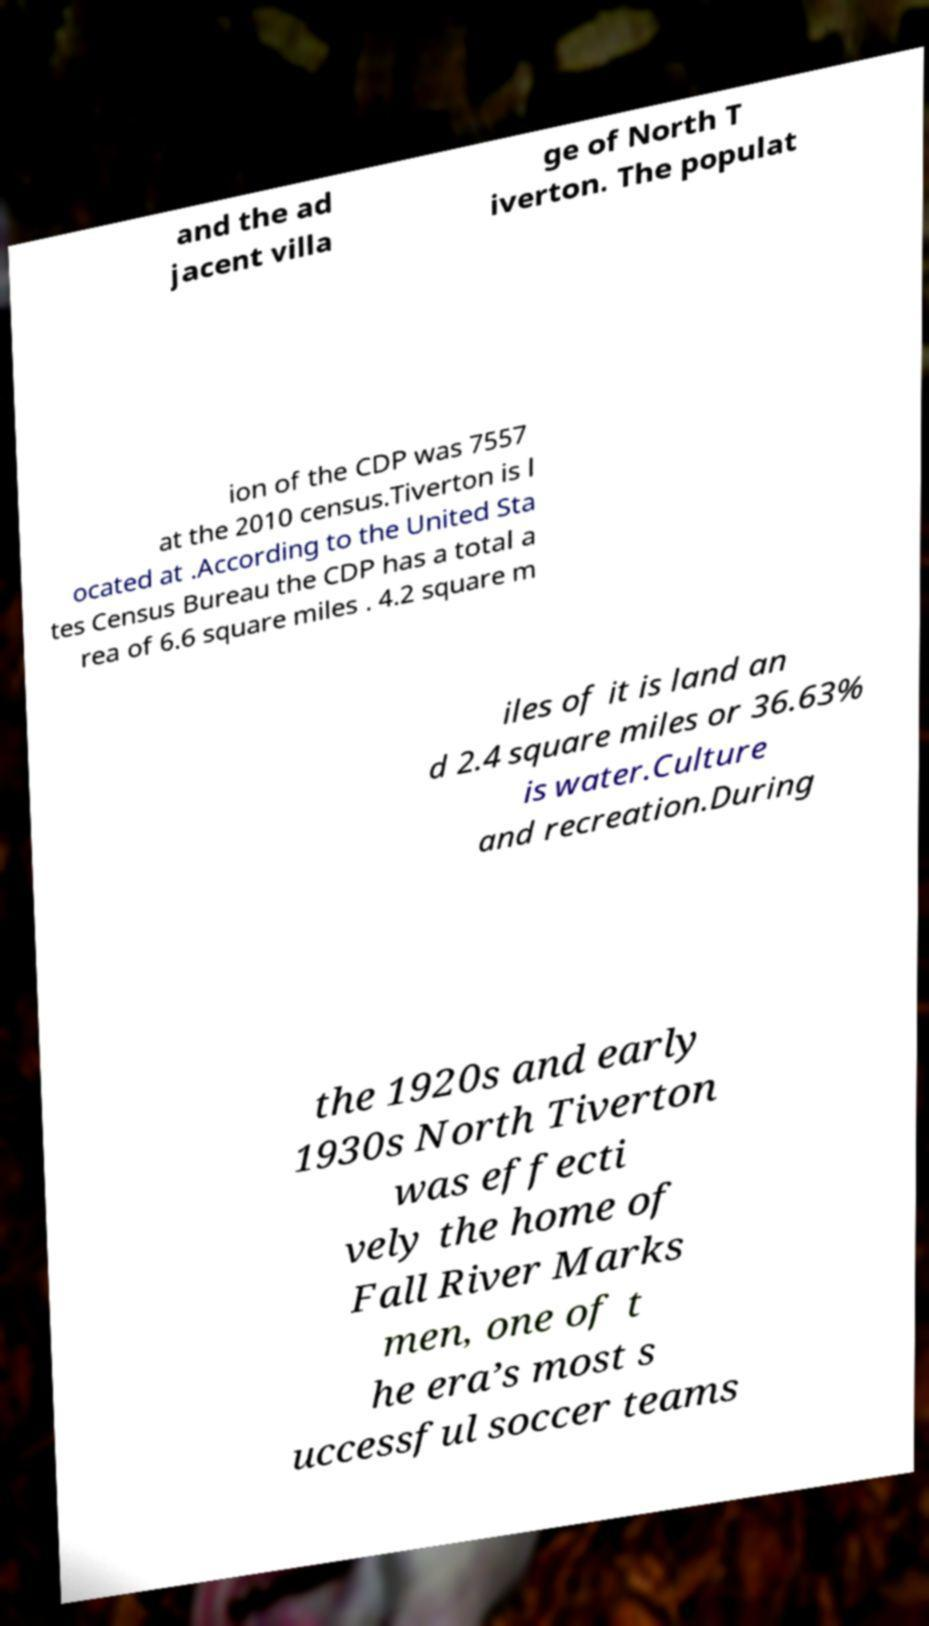Could you assist in decoding the text presented in this image and type it out clearly? and the ad jacent villa ge of North T iverton. The populat ion of the CDP was 7557 at the 2010 census.Tiverton is l ocated at .According to the United Sta tes Census Bureau the CDP has a total a rea of 6.6 square miles . 4.2 square m iles of it is land an d 2.4 square miles or 36.63% is water.Culture and recreation.During the 1920s and early 1930s North Tiverton was effecti vely the home of Fall River Marks men, one of t he era’s most s uccessful soccer teams 